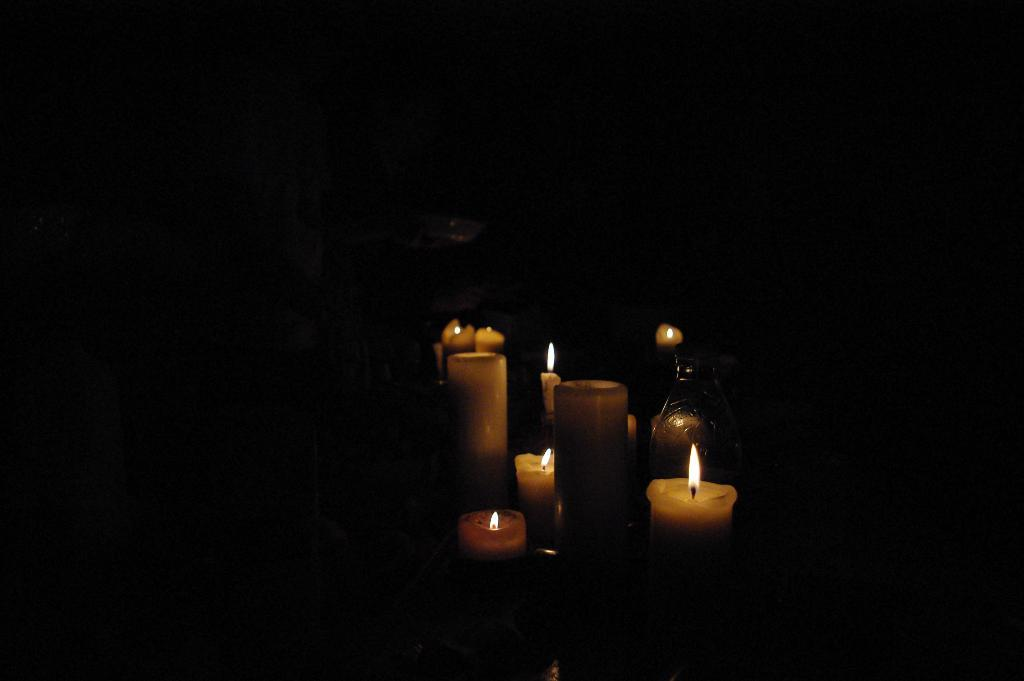What type of objects can be seen in the image? There are candles and a glass object in the image. What is the color of the background in the image? The background of the image is black. What type of noise can be heard coming from the candles in the image? There is no noise coming from the candles in the image, as candles do not produce sound. Is there a net visible in the image? No, there is no net present in the image. 